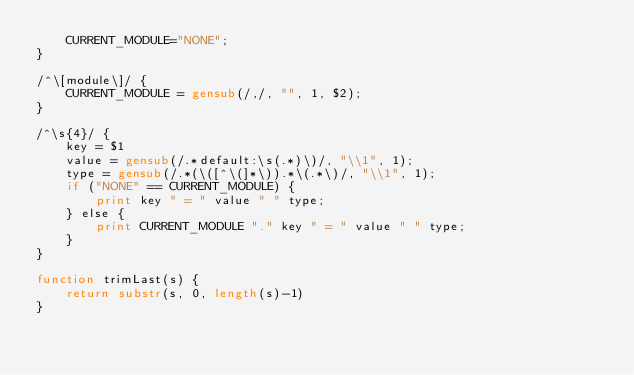Convert code to text. <code><loc_0><loc_0><loc_500><loc_500><_Awk_>    CURRENT_MODULE="NONE";
}

/^\[module\]/ {
    CURRENT_MODULE = gensub(/,/, "", 1, $2);
}

/^\s{4}/ {
    key = $1
    value = gensub(/.*default:\s(.*)\)/, "\\1", 1);
    type = gensub(/.*(\([^\(]*\)).*\(.*\)/, "\\1", 1);
    if ("NONE" == CURRENT_MODULE) {
        print key " = " value " " type;
    } else {
        print CURRENT_MODULE "." key " = " value " " type;
    }
}

function trimLast(s) {
    return substr(s, 0, length(s)-1)
}
</code> 